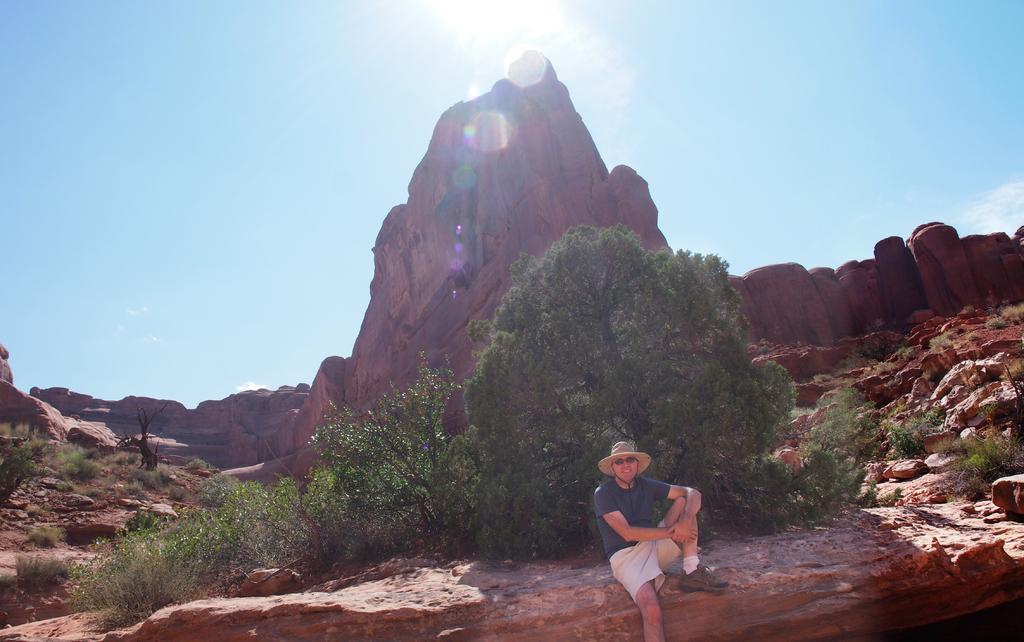What is the person in the image doing? There is a person sitting in the image. What can be seen behind the person? There are trees and rocks visible in the background of the image. What is visible in the sky in the image? The sky is visible in the background of the image. What type of zinc object can be seen in the hands of the person in the image? There is no zinc object present in the image. What emotion is the person in the image expressing towards the hen? There is no hen present in the image, so it is not possible to determine any emotions towards a hen. 